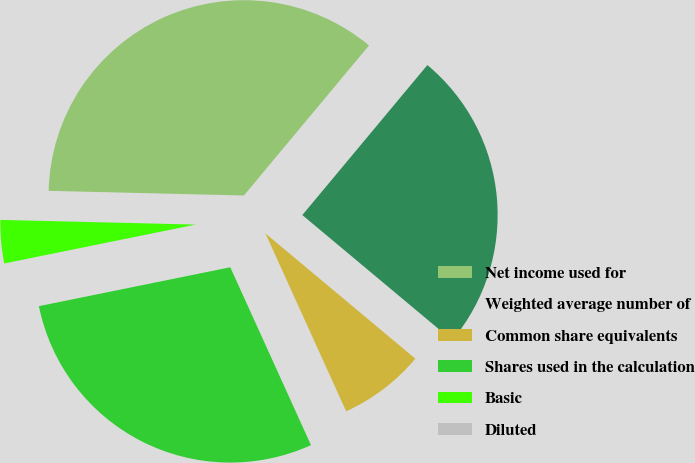<chart> <loc_0><loc_0><loc_500><loc_500><pie_chart><fcel>Net income used for<fcel>Weighted average number of<fcel>Common share equivalents<fcel>Shares used in the calculation<fcel>Basic<fcel>Diluted<nl><fcel>35.68%<fcel>25.02%<fcel>7.14%<fcel>28.59%<fcel>3.57%<fcel>0.0%<nl></chart> 